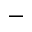Convert formula to latex. <formula><loc_0><loc_0><loc_500><loc_500>-</formula> 